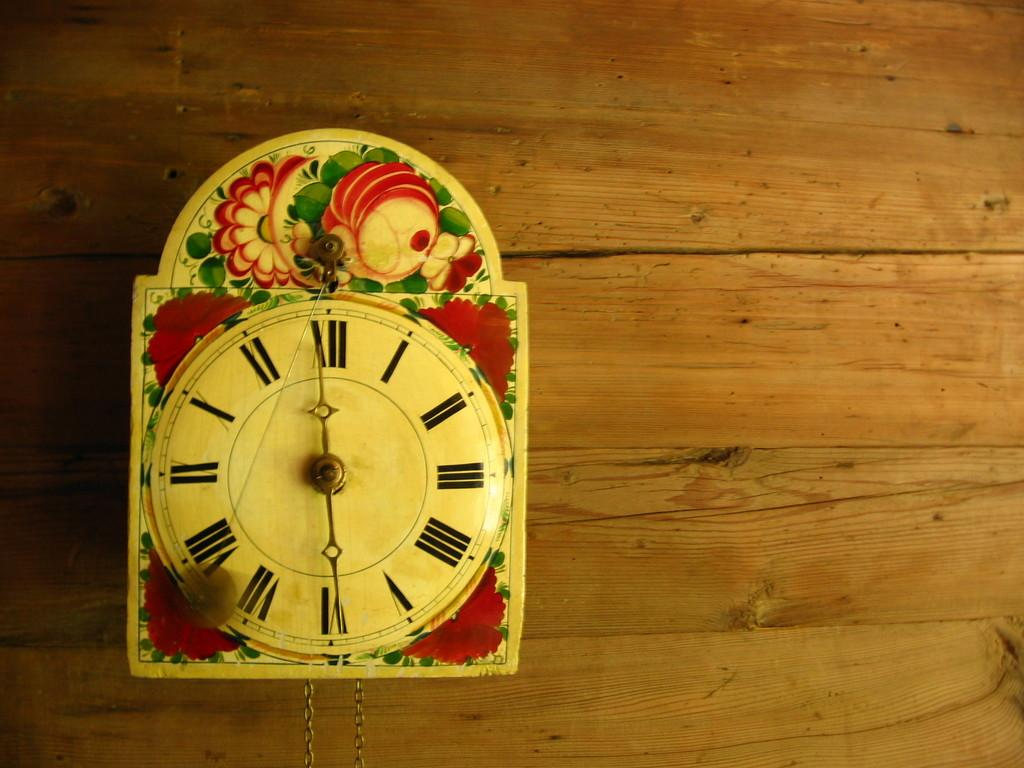<image>
Render a clear and concise summary of the photo. The colorful clock has Roman numerals and the time is 12:30. 